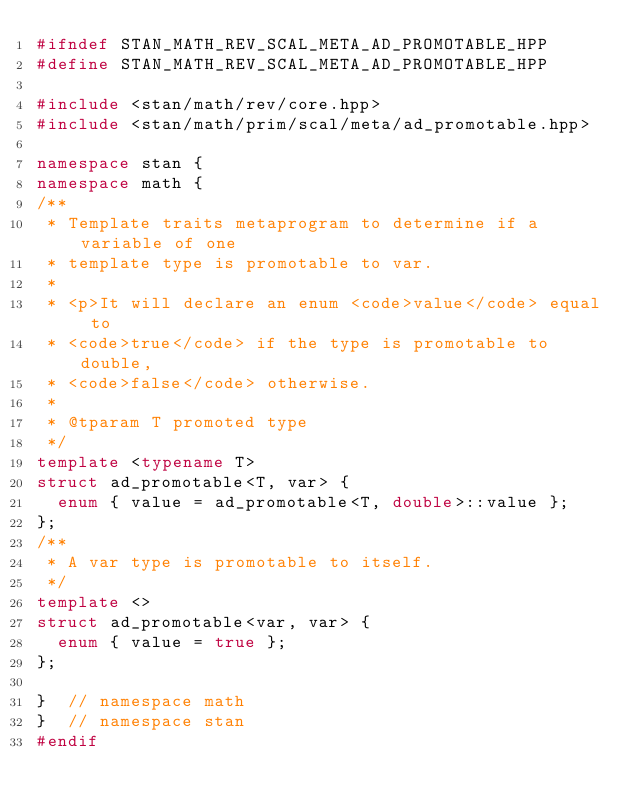Convert code to text. <code><loc_0><loc_0><loc_500><loc_500><_C++_>#ifndef STAN_MATH_REV_SCAL_META_AD_PROMOTABLE_HPP
#define STAN_MATH_REV_SCAL_META_AD_PROMOTABLE_HPP

#include <stan/math/rev/core.hpp>
#include <stan/math/prim/scal/meta/ad_promotable.hpp>

namespace stan {
namespace math {
/**
 * Template traits metaprogram to determine if a variable of one
 * template type is promotable to var.
 *
 * <p>It will declare an enum <code>value</code> equal to
 * <code>true</code> if the type is promotable to double,
 * <code>false</code> otherwise.
 *
 * @tparam T promoted type
 */
template <typename T>
struct ad_promotable<T, var> {
  enum { value = ad_promotable<T, double>::value };
};
/**
 * A var type is promotable to itself.
 */
template <>
struct ad_promotable<var, var> {
  enum { value = true };
};

}  // namespace math
}  // namespace stan
#endif
</code> 